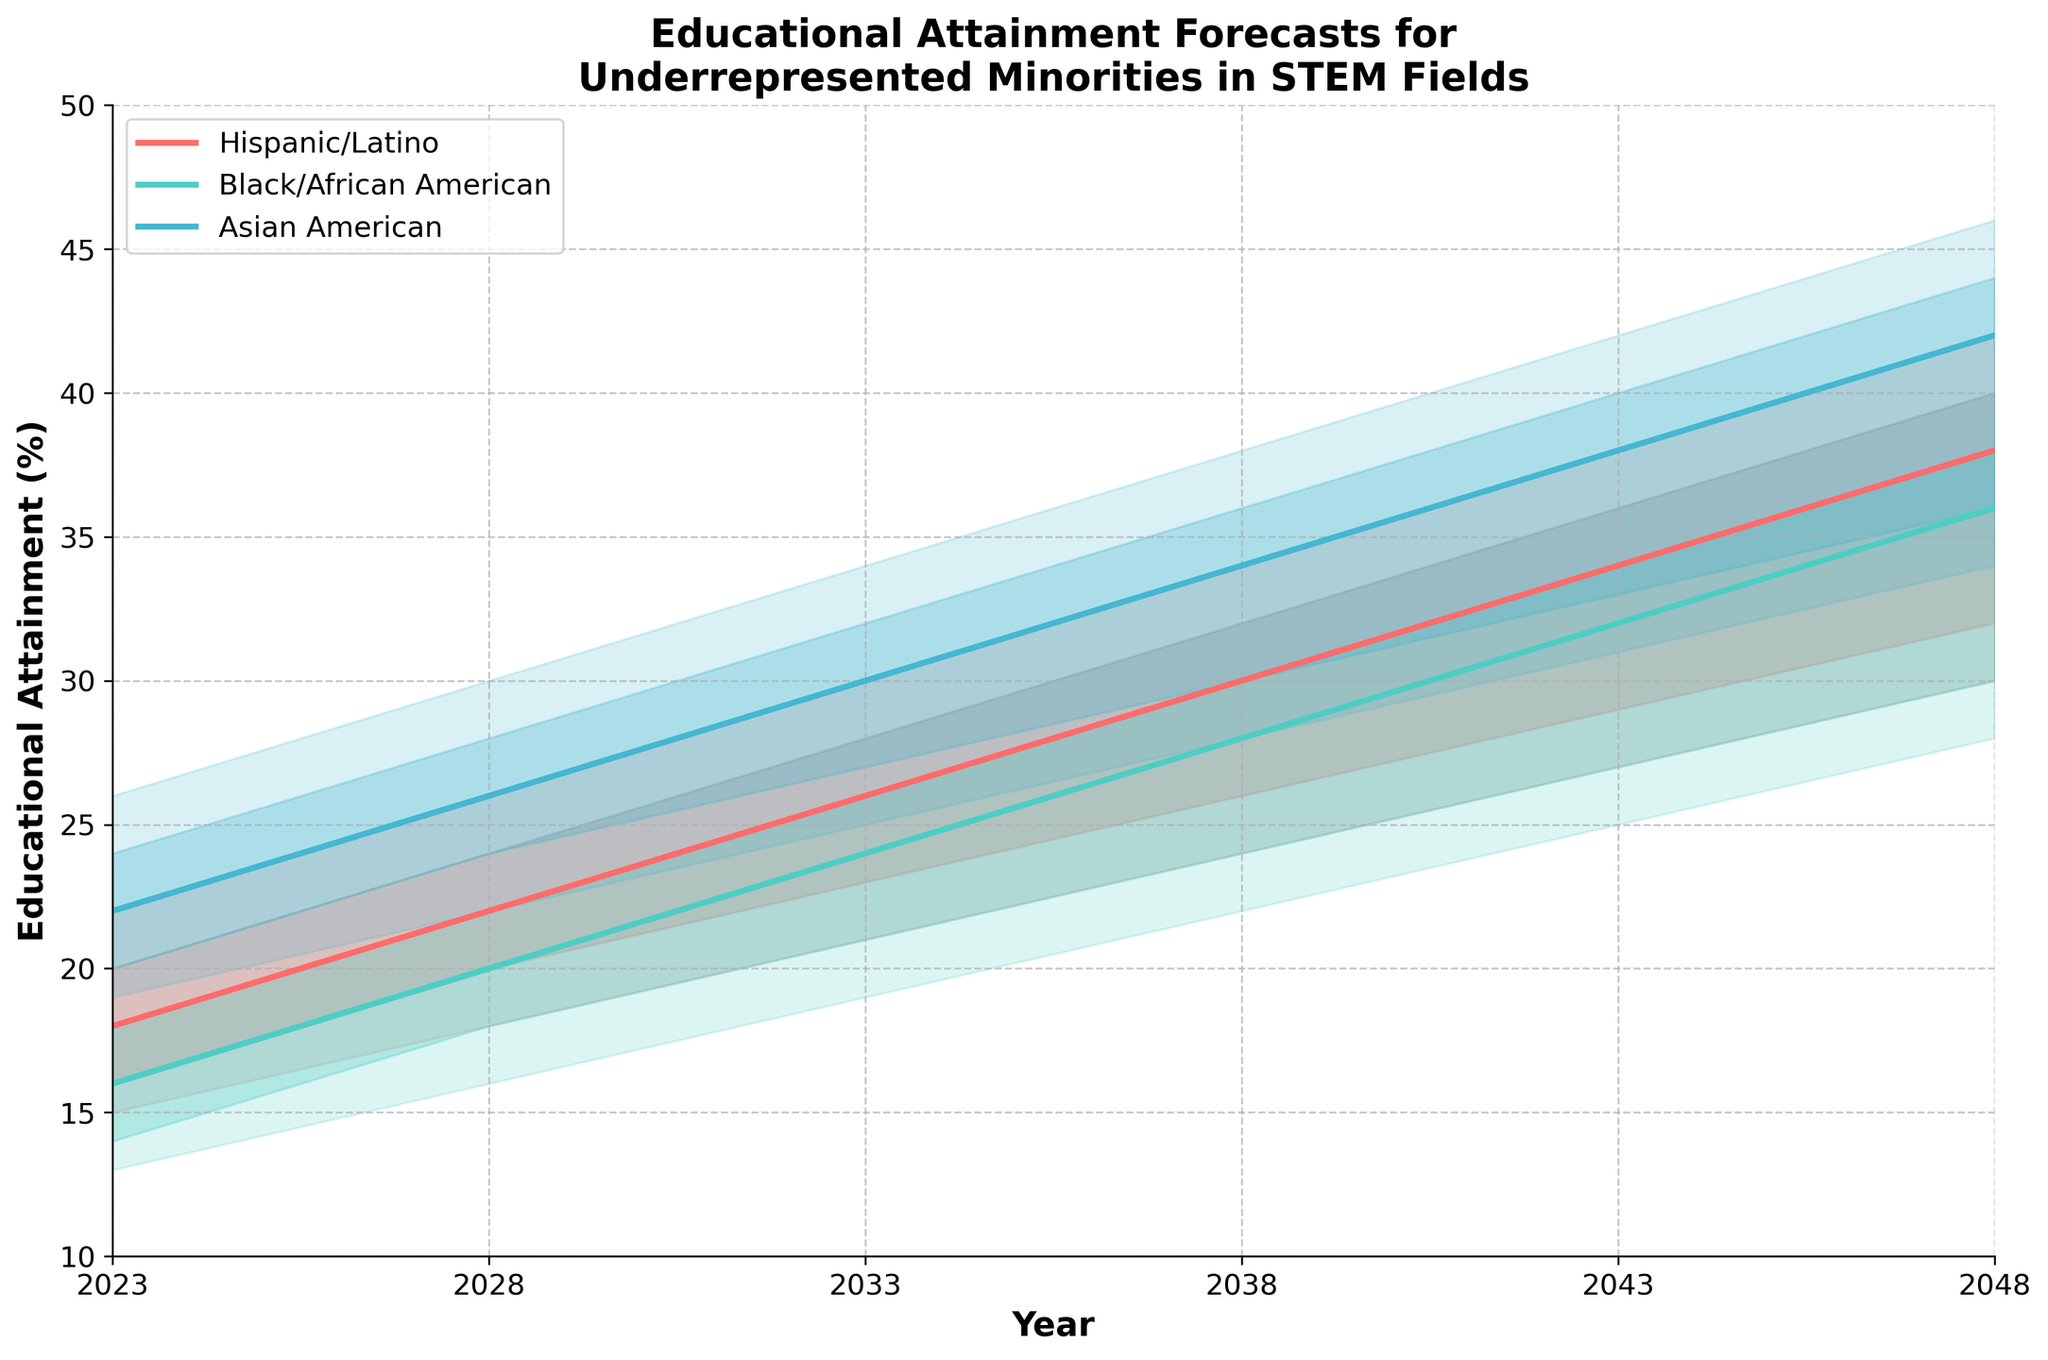What is the title of the chart? The title is prominently displayed at the top of the chart, indicating the subject matter.
Answer: Educational Attainment Forecasts for Underrepresented Minorities in STEM Fields What is the range of years shown on the x-axis? The x-axis shows the years being forecasted, from the starting year to the ending year.
Answer: 2023 to 2048 What colors represent the different groups? By observing the plot, we can see which colors correspond to each ethnic group.
Answer: Hispanic/Latino (red), Black/African American (teal), Asian American (blue) What is the median educational attainment of Black/African American in 2023? The corresponding median value for the year 2023 and the indicated group can be found by checking the plot's median line.
Answer: 16% Between which years does the educational attainment of Hispanic/Latino cross 30%? To find when the attainment crosses 30%, locate the median line of Hispanic/Latino and see when it exceeds 30% on the y-axis.
Answer: Between 2038 and 2043 Which group shows the highest median educational attainment in 2048? By comparing the median lines of each group at the year 2048, it's evident which group has the highest attainment.
Answer: Asian American What is the interval of educational attainment for Asian American in 2033, according to 80% confidence? This requires identifying and comparing the lower and upper bounds (Upper80 and Lower20) for the confidence interval in the year 2033.
Answer: 27% to 32% How much did the median educational attainment increase for Black/African American from 2023 to 2048? Calculate the difference in the median from 2048 and 2023 for Black/African American.
Answer: 20% - 16% = 20 Compare the educational attainment range (Upper90 - Lower10) for Hispanic/Latino in 2023 and 2048. Which year has a larger range? Calculate and compare the range of educational attainment for both years for Hispanic/Latino.
Answer: 2048: 42% - 30% = 12%, 2023: 22% - 15% = 7%, 2048 has a larger range 